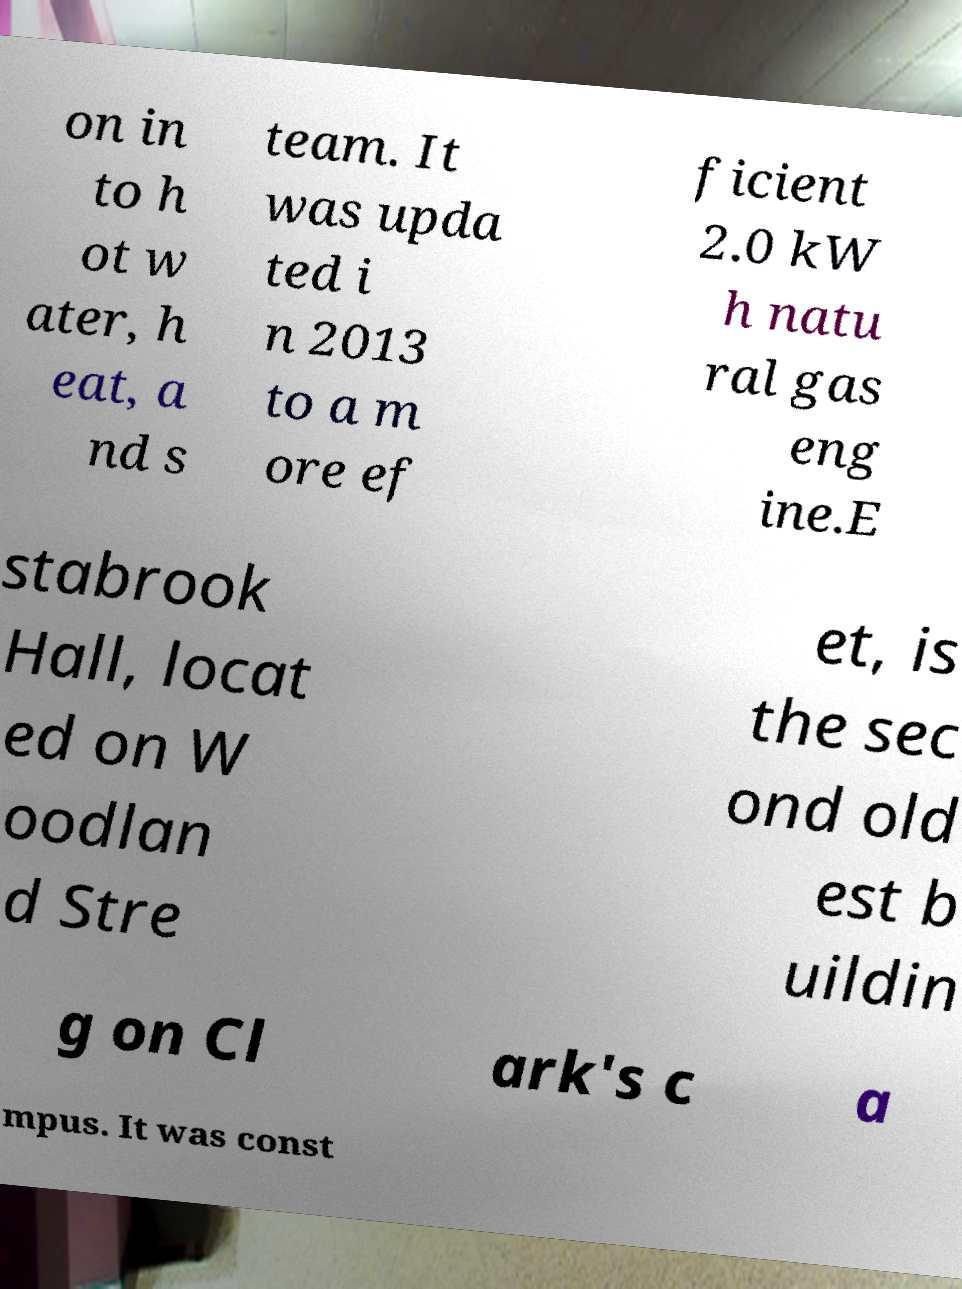Could you extract and type out the text from this image? on in to h ot w ater, h eat, a nd s team. It was upda ted i n 2013 to a m ore ef ficient 2.0 kW h natu ral gas eng ine.E stabrook Hall, locat ed on W oodlan d Stre et, is the sec ond old est b uildin g on Cl ark's c a mpus. It was const 